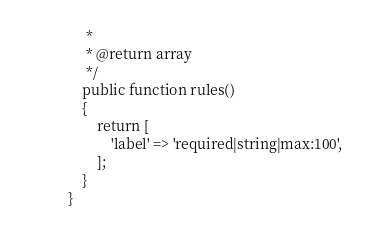Convert code to text. <code><loc_0><loc_0><loc_500><loc_500><_PHP_>     *
     * @return array
     */
    public function rules()
    {
        return [
            'label' => 'required|string|max:100',
        ];
    }
}
</code> 